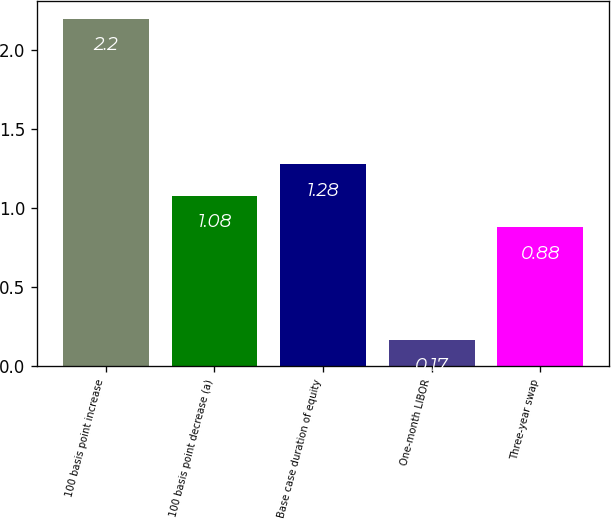Convert chart. <chart><loc_0><loc_0><loc_500><loc_500><bar_chart><fcel>100 basis point increase<fcel>100 basis point decrease (a)<fcel>Base case duration of equity<fcel>One-month LIBOR<fcel>Three-year swap<nl><fcel>2.2<fcel>1.08<fcel>1.28<fcel>0.17<fcel>0.88<nl></chart> 